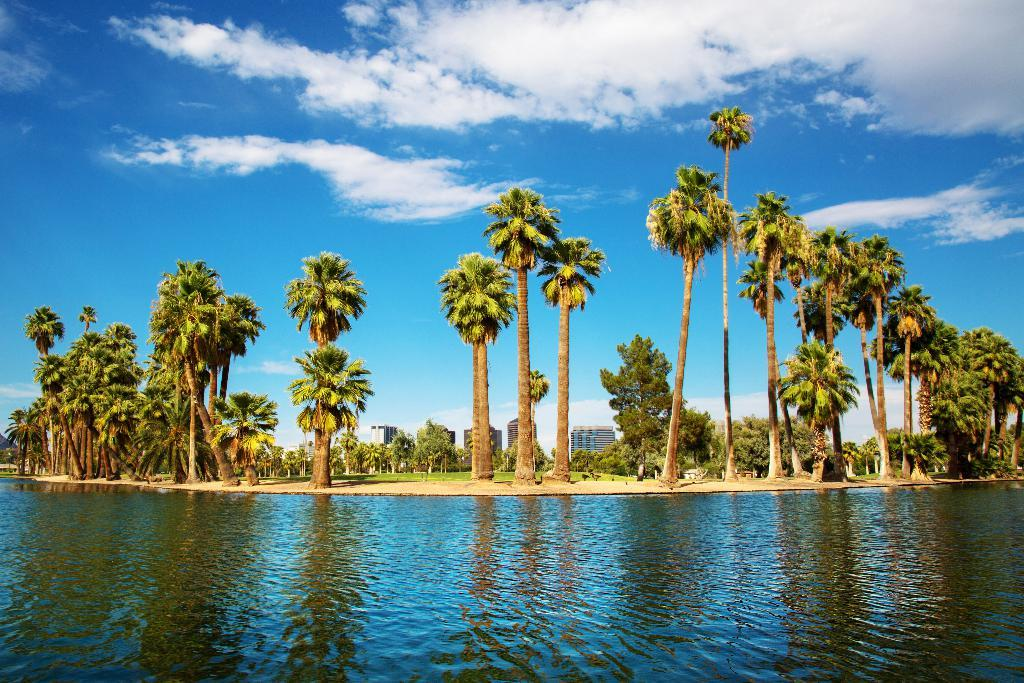What is present at the bottom of the image? There is water at the bottom of the image. What can be seen in the background of the image? There are trees, buildings, and grass on the ground in the background of the image. How would you describe the sky in the image? The sky is blue and has clouds in it. How many crates are stacked next to the trees in the image? There are no crates present in the image. What type of houses can be seen in the image? There are no houses present in the image; only buildings are mentioned. 